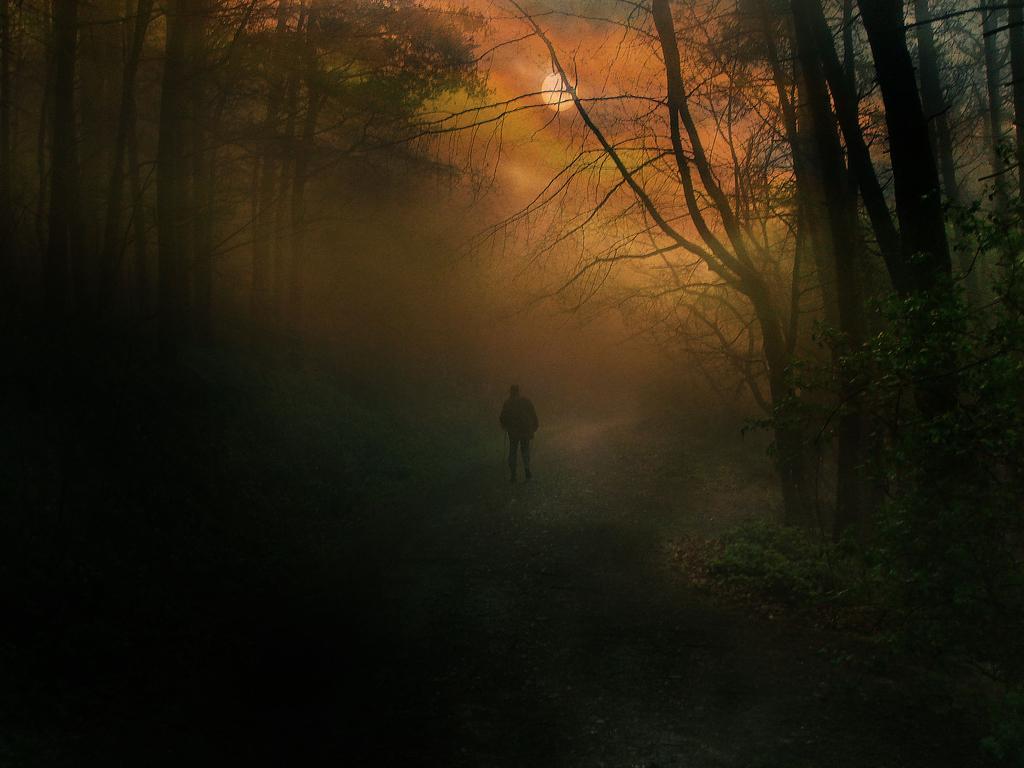Describe this image in one or two sentences. In this image we can see an edited picture of a person holding stick is standing on the ground. In the background, we can see a group of trees and moon in the sky. 